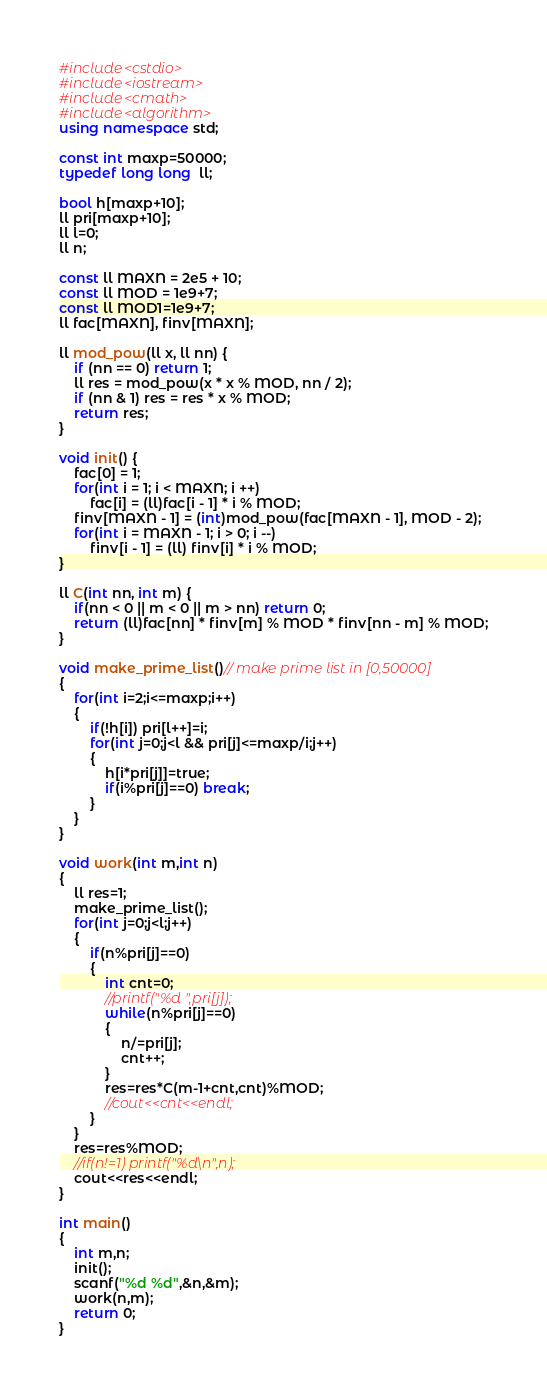<code> <loc_0><loc_0><loc_500><loc_500><_C++_>#include<cstdio>
#include<iostream>
#include<cmath>
#include<algorithm>
using namespace std;

const int maxp=50000;
typedef long long  ll;

bool h[maxp+10];
ll pri[maxp+10];
ll l=0;
ll n;

const ll MAXN = 2e5 + 10;
const ll MOD = 1e9+7;
const ll MOD1=1e9+7;
ll fac[MAXN], finv[MAXN];
 
ll mod_pow(ll x, ll nn) {
    if (nn == 0) return 1;
    ll res = mod_pow(x * x % MOD, nn / 2);
    if (nn & 1) res = res * x % MOD;
    return res;
}
 
void init() {
    fac[0] = 1;
    for(int i = 1; i < MAXN; i ++)
        fac[i] = (ll)fac[i - 1] * i % MOD;
    finv[MAXN - 1] = (int)mod_pow(fac[MAXN - 1], MOD - 2);
    for(int i = MAXN - 1; i > 0; i --)
        finv[i - 1] = (ll) finv[i] * i % MOD;
}
 
ll C(int nn, int m) {
    if(nn < 0 || m < 0 || m > nn) return 0;
    return (ll)fac[nn] * finv[m] % MOD * finv[nn - m] % MOD;
}

void make_prime_list()// make prime list in [0,50000]
{
	for(int i=2;i<=maxp;i++)
	{
		if(!h[i]) pri[l++]=i;
		for(int j=0;j<l && pri[j]<=maxp/i;j++)
		{
			h[i*pri[j]]=true;
			if(i%pri[j]==0) break;
		}
	}
}

void work(int m,int n)
{
	ll res=1;
	make_prime_list();
	for(int j=0;j<l;j++)
	{
		if(n%pri[j]==0)
		{
			int cnt=0;
			//printf("%d ",pri[j]);
			while(n%pri[j]==0) 
			{
				n/=pri[j];
				cnt++;
			}
			res=res*C(m-1+cnt,cnt)%MOD;
			//cout<<cnt<<endl;
		}
	}
	res=res%MOD;
	//if(n!=1) printf("%d\n",n);
	cout<<res<<endl;
}

int main()
{
	int m,n;
	init();
	scanf("%d %d",&n,&m);
	work(n,m);
	return 0;
}</code> 